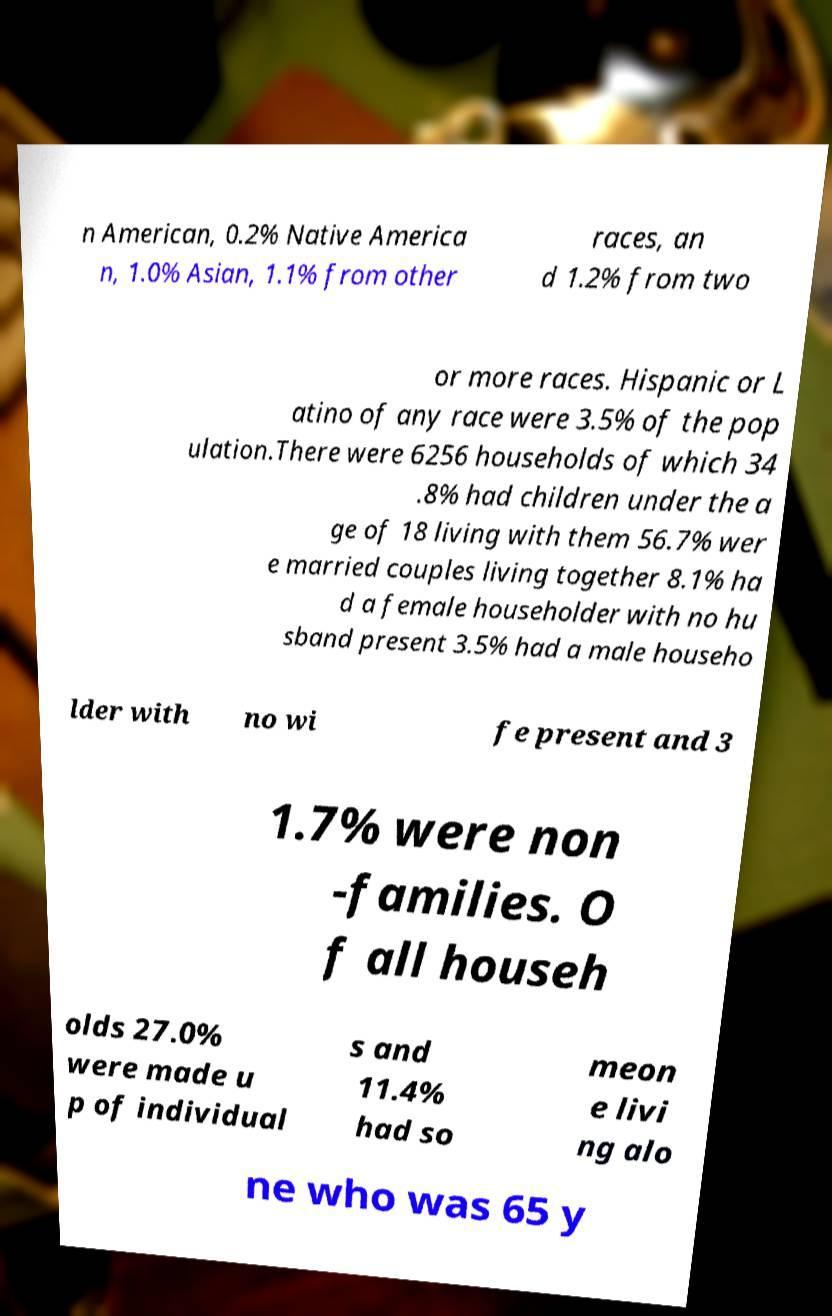What messages or text are displayed in this image? I need them in a readable, typed format. n American, 0.2% Native America n, 1.0% Asian, 1.1% from other races, an d 1.2% from two or more races. Hispanic or L atino of any race were 3.5% of the pop ulation.There were 6256 households of which 34 .8% had children under the a ge of 18 living with them 56.7% wer e married couples living together 8.1% ha d a female householder with no hu sband present 3.5% had a male househo lder with no wi fe present and 3 1.7% were non -families. O f all househ olds 27.0% were made u p of individual s and 11.4% had so meon e livi ng alo ne who was 65 y 